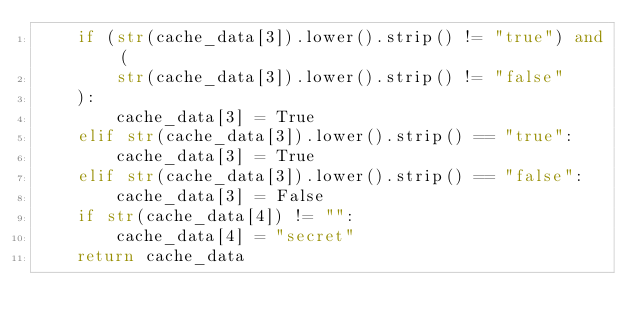<code> <loc_0><loc_0><loc_500><loc_500><_Python_>    if (str(cache_data[3]).lower().strip() != "true") and (
        str(cache_data[3]).lower().strip() != "false"
    ):
        cache_data[3] = True
    elif str(cache_data[3]).lower().strip() == "true":
        cache_data[3] = True
    elif str(cache_data[3]).lower().strip() == "false":
        cache_data[3] = False
    if str(cache_data[4]) != "":
        cache_data[4] = "secret"
    return cache_data
</code> 